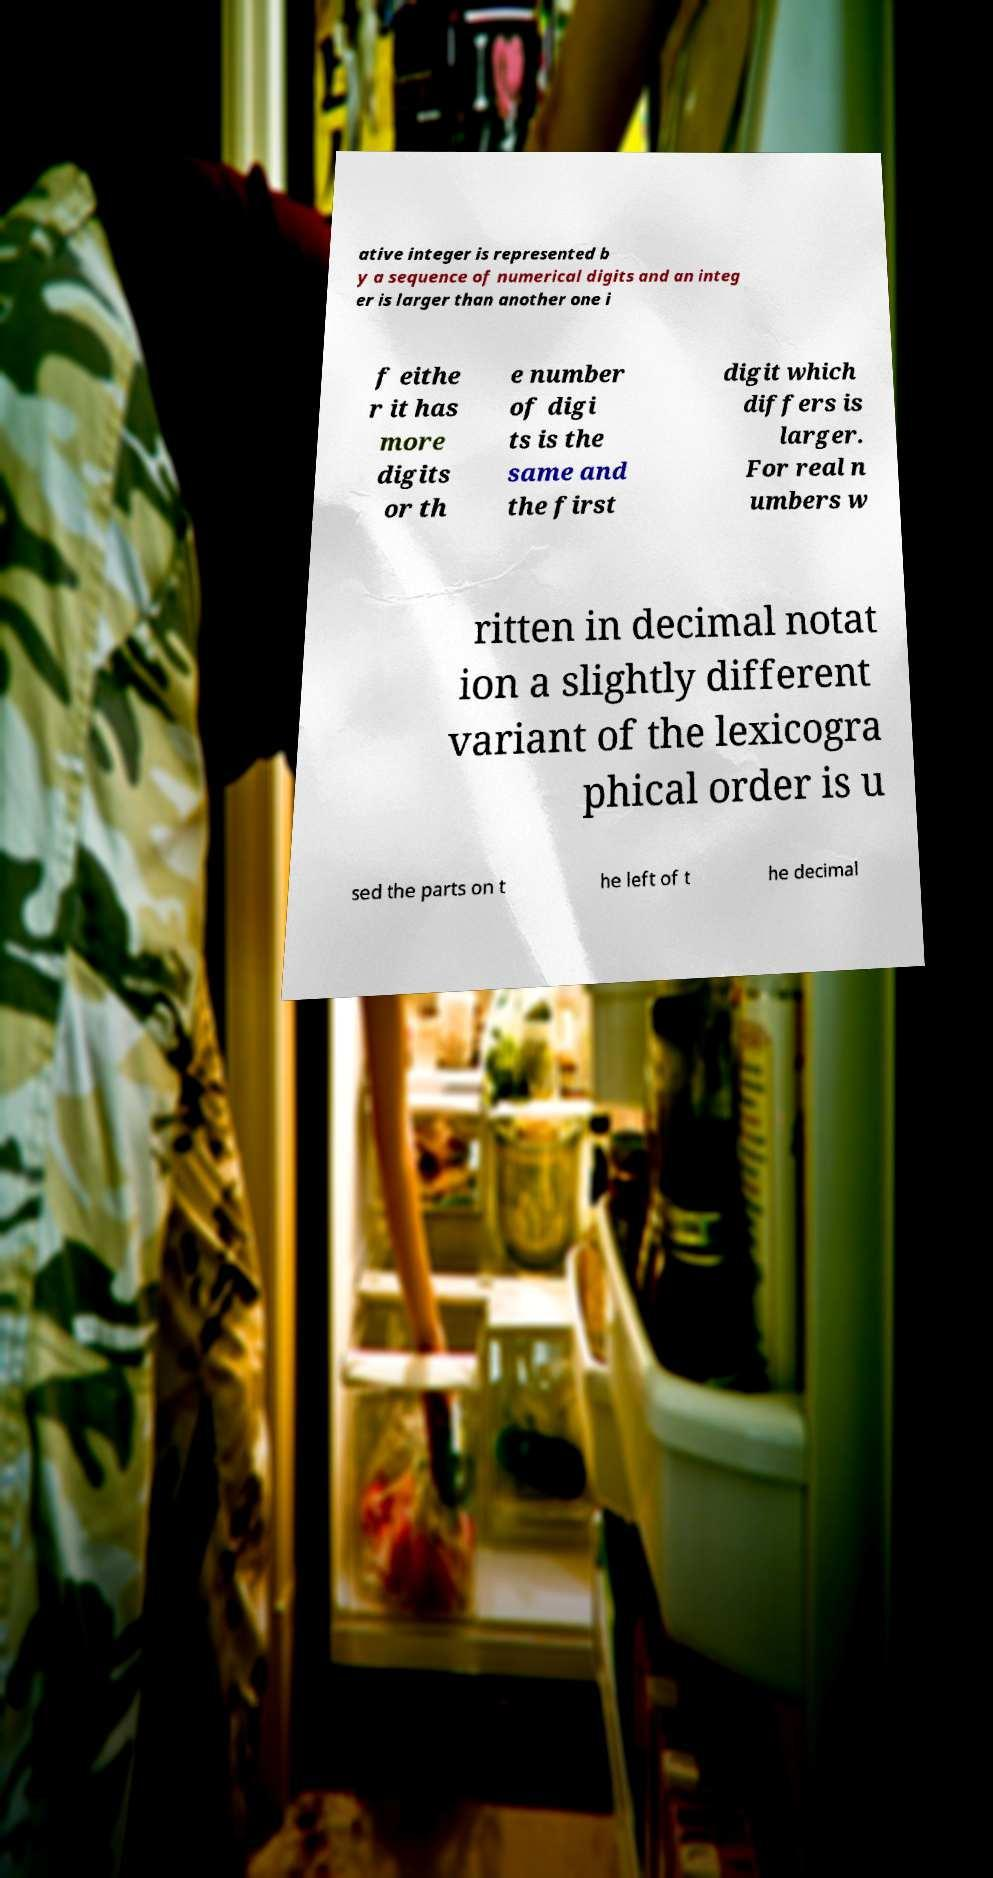For documentation purposes, I need the text within this image transcribed. Could you provide that? ative integer is represented b y a sequence of numerical digits and an integ er is larger than another one i f eithe r it has more digits or th e number of digi ts is the same and the first digit which differs is larger. For real n umbers w ritten in decimal notat ion a slightly different variant of the lexicogra phical order is u sed the parts on t he left of t he decimal 